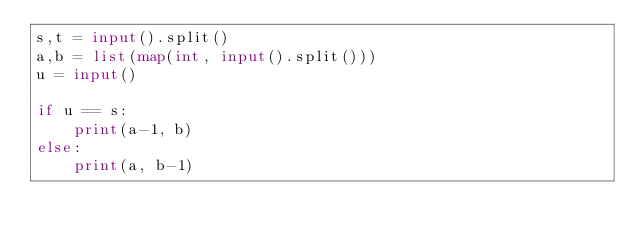Convert code to text. <code><loc_0><loc_0><loc_500><loc_500><_Python_>s,t = input().split()
a,b = list(map(int, input().split()))
u = input()

if u == s:
    print(a-1, b)
else:
    print(a, b-1)</code> 